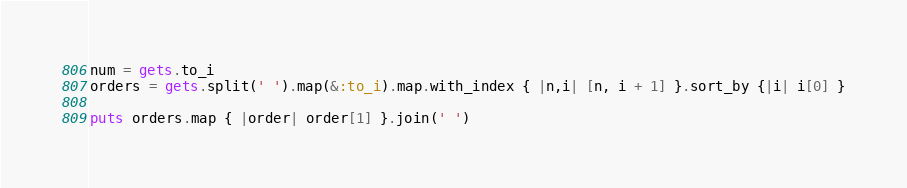Convert code to text. <code><loc_0><loc_0><loc_500><loc_500><_Ruby_>num = gets.to_i
orders = gets.split(' ').map(&:to_i).map.with_index { |n,i| [n, i + 1] }.sort_by {|i| i[0] }

puts orders.map { |order| order[1] }.join(' ')</code> 